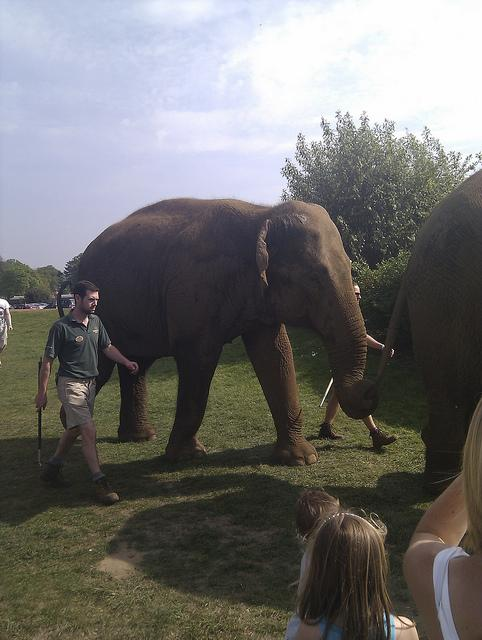What is the woman in white shirt likely to be doing? Please explain your reasoning. taking photo. Though out of the frame, the woman appears to be holding her arm up in a manner consistent with photography. people tend to take photos when they're in a place that has elephants. 